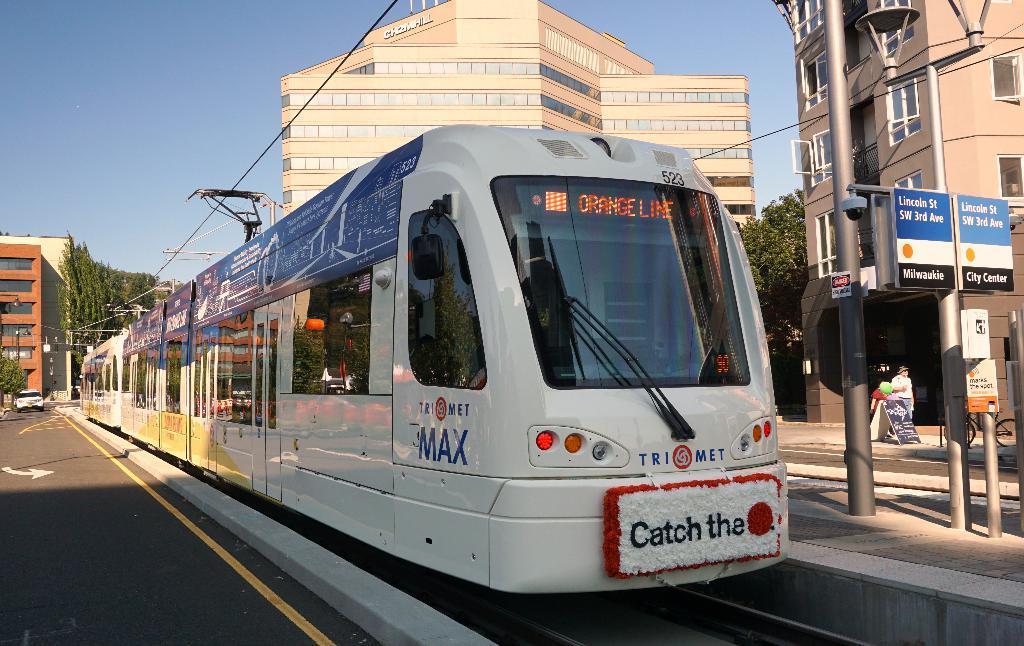Can you describe this image briefly? In this image I can see a train which is in white color on the track. Background I can see few buildings in brown and cream color, trees in green color and sky in blue color. 